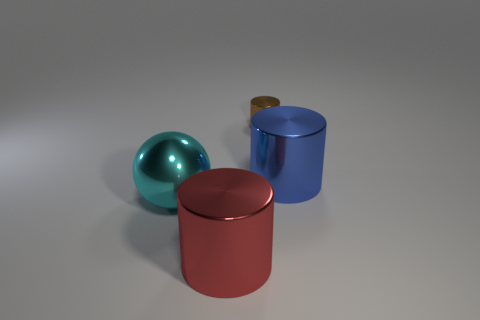How many big red cylinders have the same material as the big cyan thing?
Your answer should be compact. 1. The blue shiny thing that is the same shape as the red object is what size?
Offer a very short reply. Large. Are there any brown metal objects to the left of the red cylinder?
Provide a short and direct response. No. Are there any other things that have the same shape as the cyan object?
Ensure brevity in your answer.  No. The other big object that is the same shape as the big red thing is what color?
Offer a terse response. Blue. There is a large thing right of the big red metal cylinder; what is its material?
Ensure brevity in your answer.  Metal. What is the color of the metallic sphere?
Your response must be concise. Cyan. Is the size of the shiny thing that is behind the blue cylinder the same as the big sphere?
Keep it short and to the point. No. What is the material of the cylinder that is left of the small cylinder that is behind the large cyan object?
Provide a succinct answer. Metal. What is the color of the ball that is the same size as the blue object?
Provide a succinct answer. Cyan. 